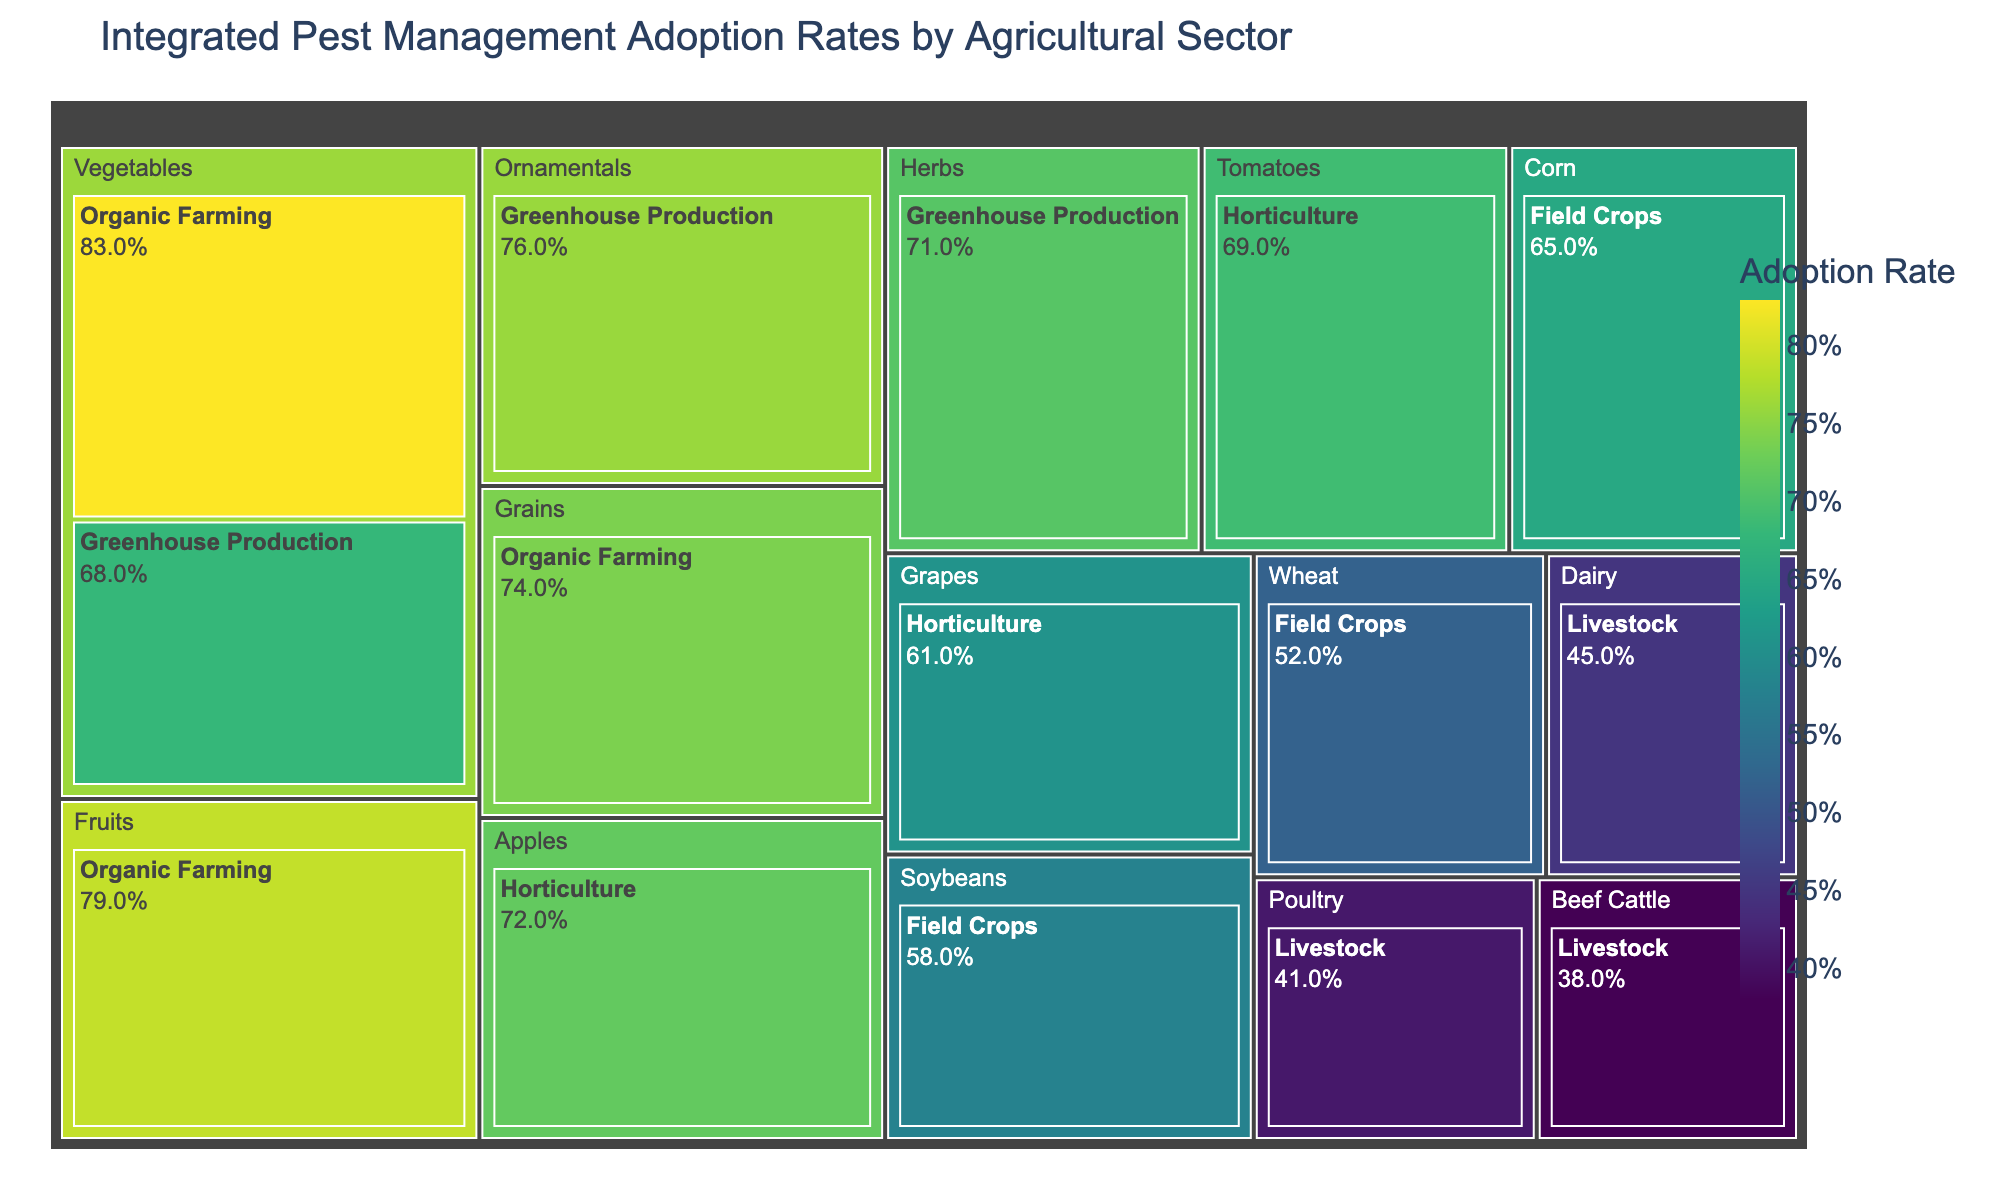What's the title of the figure? The title of the figure is prominently displayed at the top of the Treemap. We can directly read it to understand the context of the data being shown.
Answer: Integrated Pest Management Adoption Rates by Agricultural Sector Which category within Organic Farming has the highest adoption rate? By looking at the Treemap and hovering over the sections within Organic Farming, we can observe that the Vegetables category has the highest adoption rate.
Answer: Vegetables What is the adoption rate for Corn in the Field Crops sector? Locate the Corn category within the Field Crops sector and read the adoption rate either displayed or by hovering over the corresponding section.
Answer: 65% How do the adoption rates of Dairy and Poultry compare in the Livestock sector? First, find and compare the Dairy and Poultry sections within the Livestock sector. The adoption rate for Dairy is 45%, and for Poultry, it is 41%. Dairy has a higher adoption rate than Poultry.
Answer: Dairy: 45%, Poultry: 41% What's the average adoption rate for the Horticulture sector? The adoption rates for Horticulture categories (Apples, Tomatoes, Grapes) are 72%, 69%, and 61%. Calculate the average as follows: (72 + 69 + 61) / 3 = 67.33%.
Answer: 67.33% Which sector has the lowest adoption rate, and what is that rate? By analyzing the sectors, we find that Livestock has the lowest adoption rate, with Beef Cattle having the minimum of 38%.
Answer: Livestock, 38% What is the range of adoption rates for the Greenhouse Production sector? Identify the highest and lowest adoption rates in the Greenhouse Production sector. Ornamentals have the highest rate at 76%, and Vegetables have the lowest at 68%. The range is 76% - 68% = 8%.
Answer: 8% Compare the adoption rate of Vegetables in Organic Farming to Vegetables in Greenhouse Production. Which has a higher rate, and by how much? Vegetables in Organic Farming have an adoption rate of 83%, whereas in Greenhouse Production, it is 68%. The difference is calculated as 83% - 68% = 15%.
Answer: Organic Farming by 15% How does the adoption rate for Apples in Horticulture compare to Grains in Organic Farming? Locate the adoption rates for both categories: Apples in Horticulture is 72%, and Grains in Organic Farming is 74%. Grains in Organic Farming have a higher adoption rate than Apples in Horticulture.
Answer: Grains (74%) > Apples (72%) What is the median adoption rate of all categories presented in the Treemap? First, list all adoption rates: 65%, 58%, 52%, 72%, 69%, 61%, 45%, 41%, 38%, 83%, 79%, 74%, 76%, 71%, 68%. Sort the rates and find the middle value. Sorted: 38%, 41%, 45%, 52%, 58%, 61%, 65%, 68%, 69%, 71%, 72%, 74%, 76%, 79%, 83%. The middle value (median) is 68%.
Answer: 68% 